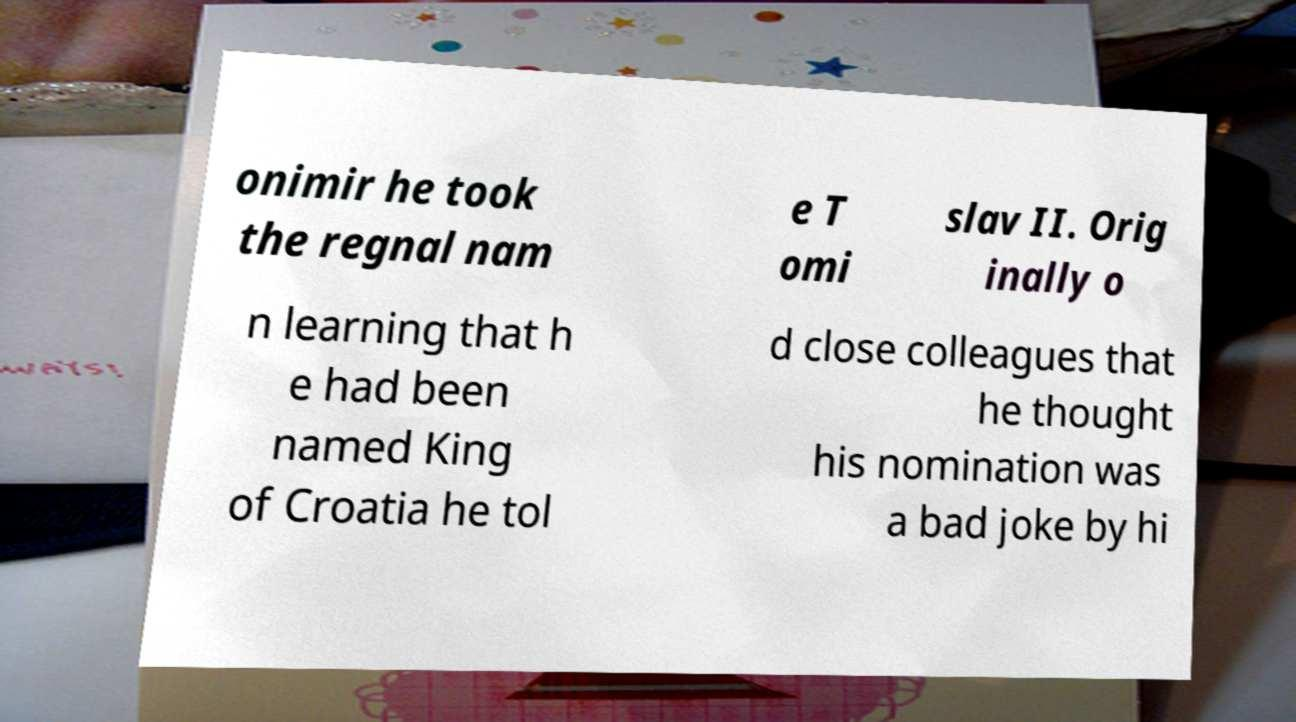For documentation purposes, I need the text within this image transcribed. Could you provide that? onimir he took the regnal nam e T omi slav II. Orig inally o n learning that h e had been named King of Croatia he tol d close colleagues that he thought his nomination was a bad joke by hi 